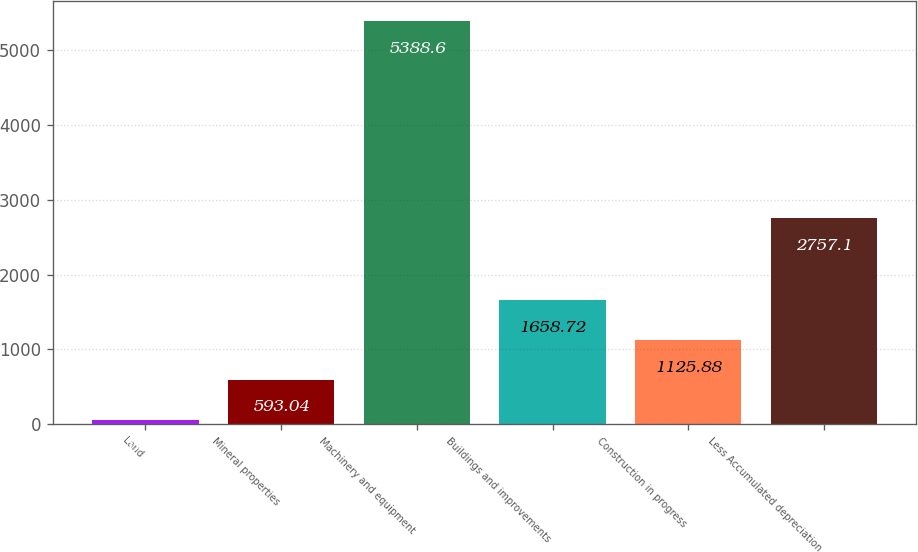<chart> <loc_0><loc_0><loc_500><loc_500><bar_chart><fcel>Land<fcel>Mineral properties<fcel>Machinery and equipment<fcel>Buildings and improvements<fcel>Construction in progress<fcel>Less Accumulated depreciation<nl><fcel>60.2<fcel>593.04<fcel>5388.6<fcel>1658.72<fcel>1125.88<fcel>2757.1<nl></chart> 